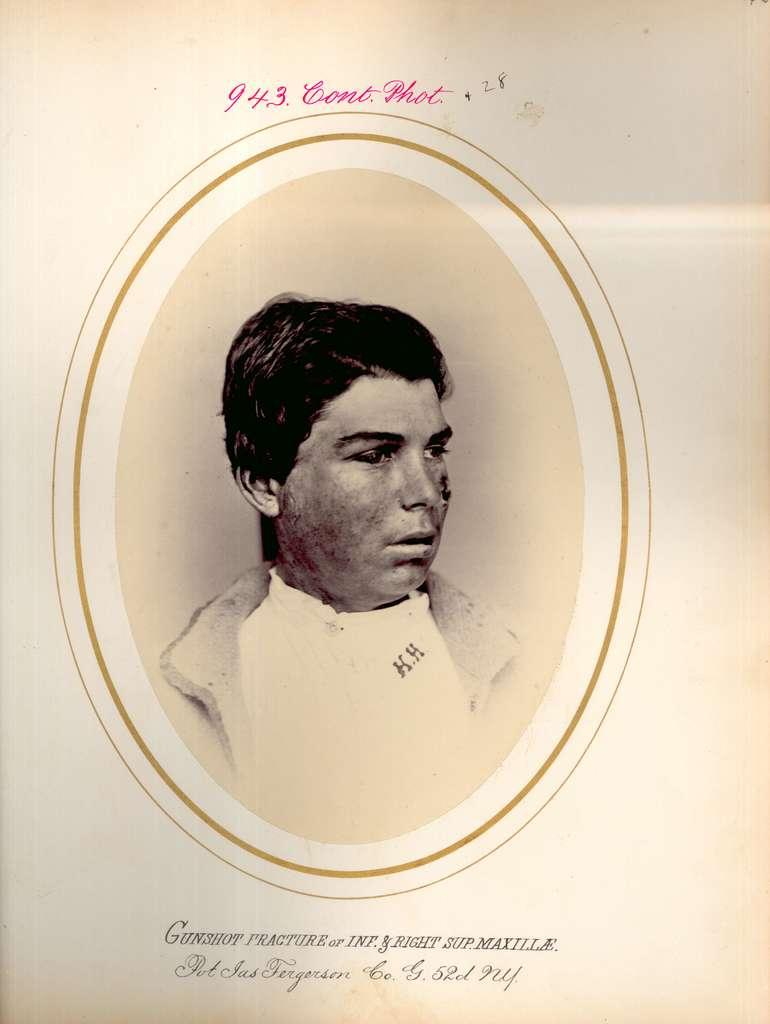Who is present in the image? There is a man in the image. What can be seen at the top portion of the image? There is some information at the top portion of the image. What can be seen at the bottom portion of the image? There is some information at the bottom portion of the image. What type of pump is visible in the image? There is no pump present in the image. What type of root can be seen growing from the man's body in the image? There is no root or body present in the image; it only features a man and some information at the top and bottom portions. 